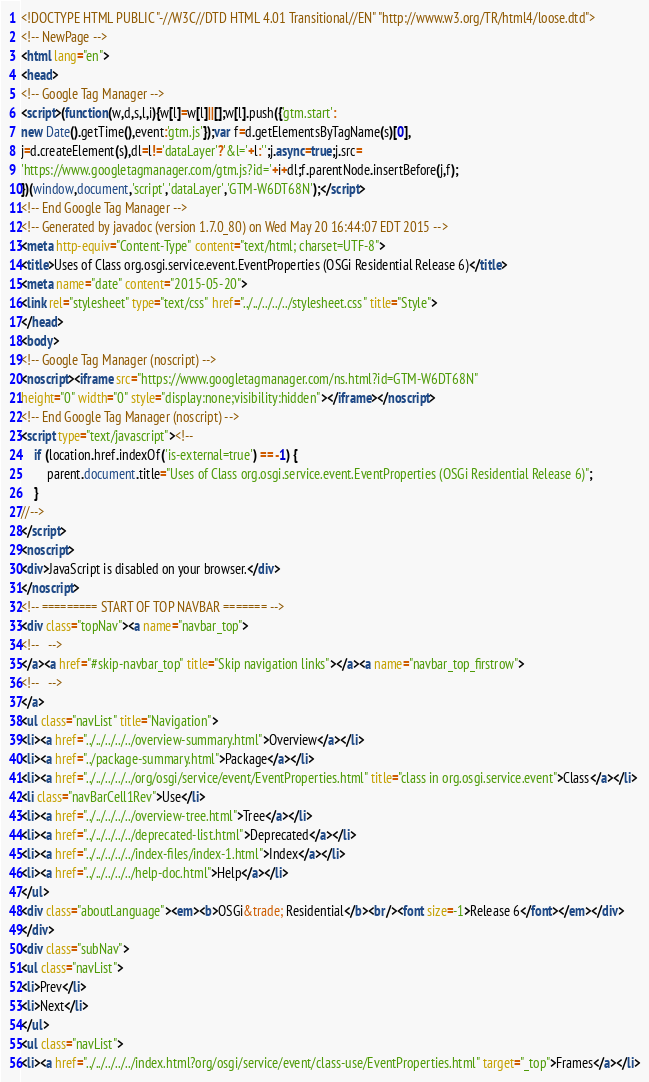Convert code to text. <code><loc_0><loc_0><loc_500><loc_500><_HTML_><!DOCTYPE HTML PUBLIC "-//W3C//DTD HTML 4.01 Transitional//EN" "http://www.w3.org/TR/html4/loose.dtd">
<!-- NewPage -->
<html lang="en">
<head>
<!-- Google Tag Manager -->
<script>(function(w,d,s,l,i){w[l]=w[l]||[];w[l].push({'gtm.start':
new Date().getTime(),event:'gtm.js'});var f=d.getElementsByTagName(s)[0],
j=d.createElement(s),dl=l!='dataLayer'?'&l='+l:'';j.async=true;j.src=
'https://www.googletagmanager.com/gtm.js?id='+i+dl;f.parentNode.insertBefore(j,f);
})(window,document,'script','dataLayer','GTM-W6DT68N');</script>
<!-- End Google Tag Manager -->
<!-- Generated by javadoc (version 1.7.0_80) on Wed May 20 16:44:07 EDT 2015 -->
<meta http-equiv="Content-Type" content="text/html; charset=UTF-8">
<title>Uses of Class org.osgi.service.event.EventProperties (OSGi Residential Release 6)</title>
<meta name="date" content="2015-05-20">
<link rel="stylesheet" type="text/css" href="../../../../../stylesheet.css" title="Style">
</head>
<body>
<!-- Google Tag Manager (noscript) -->
<noscript><iframe src="https://www.googletagmanager.com/ns.html?id=GTM-W6DT68N"
height="0" width="0" style="display:none;visibility:hidden"></iframe></noscript>
<!-- End Google Tag Manager (noscript) -->
<script type="text/javascript"><!--
    if (location.href.indexOf('is-external=true') == -1) {
        parent.document.title="Uses of Class org.osgi.service.event.EventProperties (OSGi Residential Release 6)";
    }
//-->
</script>
<noscript>
<div>JavaScript is disabled on your browser.</div>
</noscript>
<!-- ========= START OF TOP NAVBAR ======= -->
<div class="topNav"><a name="navbar_top">
<!--   -->
</a><a href="#skip-navbar_top" title="Skip navigation links"></a><a name="navbar_top_firstrow">
<!--   -->
</a>
<ul class="navList" title="Navigation">
<li><a href="../../../../../overview-summary.html">Overview</a></li>
<li><a href="../package-summary.html">Package</a></li>
<li><a href="../../../../../org/osgi/service/event/EventProperties.html" title="class in org.osgi.service.event">Class</a></li>
<li class="navBarCell1Rev">Use</li>
<li><a href="../../../../../overview-tree.html">Tree</a></li>
<li><a href="../../../../../deprecated-list.html">Deprecated</a></li>
<li><a href="../../../../../index-files/index-1.html">Index</a></li>
<li><a href="../../../../../help-doc.html">Help</a></li>
</ul>
<div class="aboutLanguage"><em><b>OSGi&trade; Residential</b><br/><font size=-1>Release 6</font></em></div>
</div>
<div class="subNav">
<ul class="navList">
<li>Prev</li>
<li>Next</li>
</ul>
<ul class="navList">
<li><a href="../../../../../index.html?org/osgi/service/event/class-use/EventProperties.html" target="_top">Frames</a></li></code> 